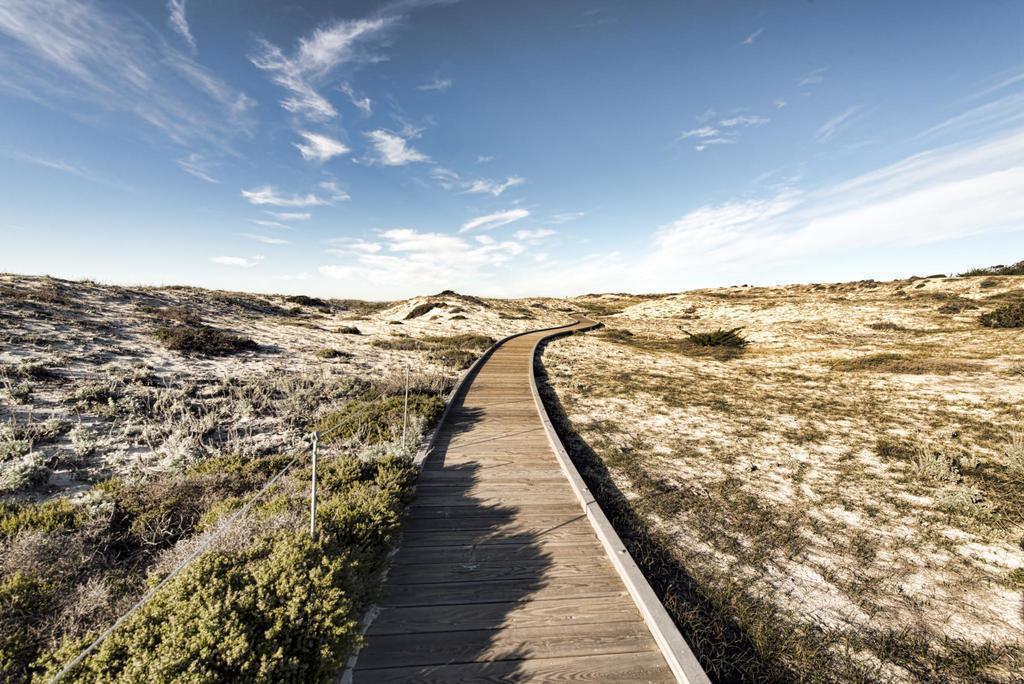Can you describe this image briefly? In this image I can see the wooden path. To the side of the path I can see the plants and the ground. In the background I can see the clouds and the blue sky. 